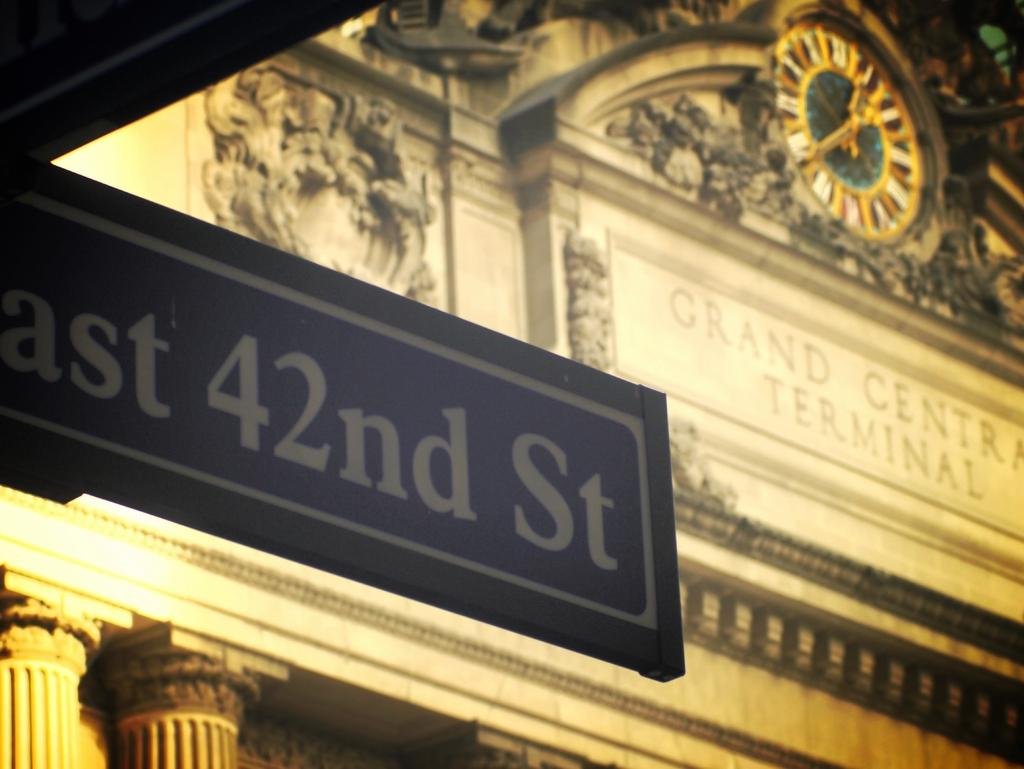<image>
Give a short and clear explanation of the subsequent image. Front of Grand Central Terminal from right behind East 42nd St sign. 